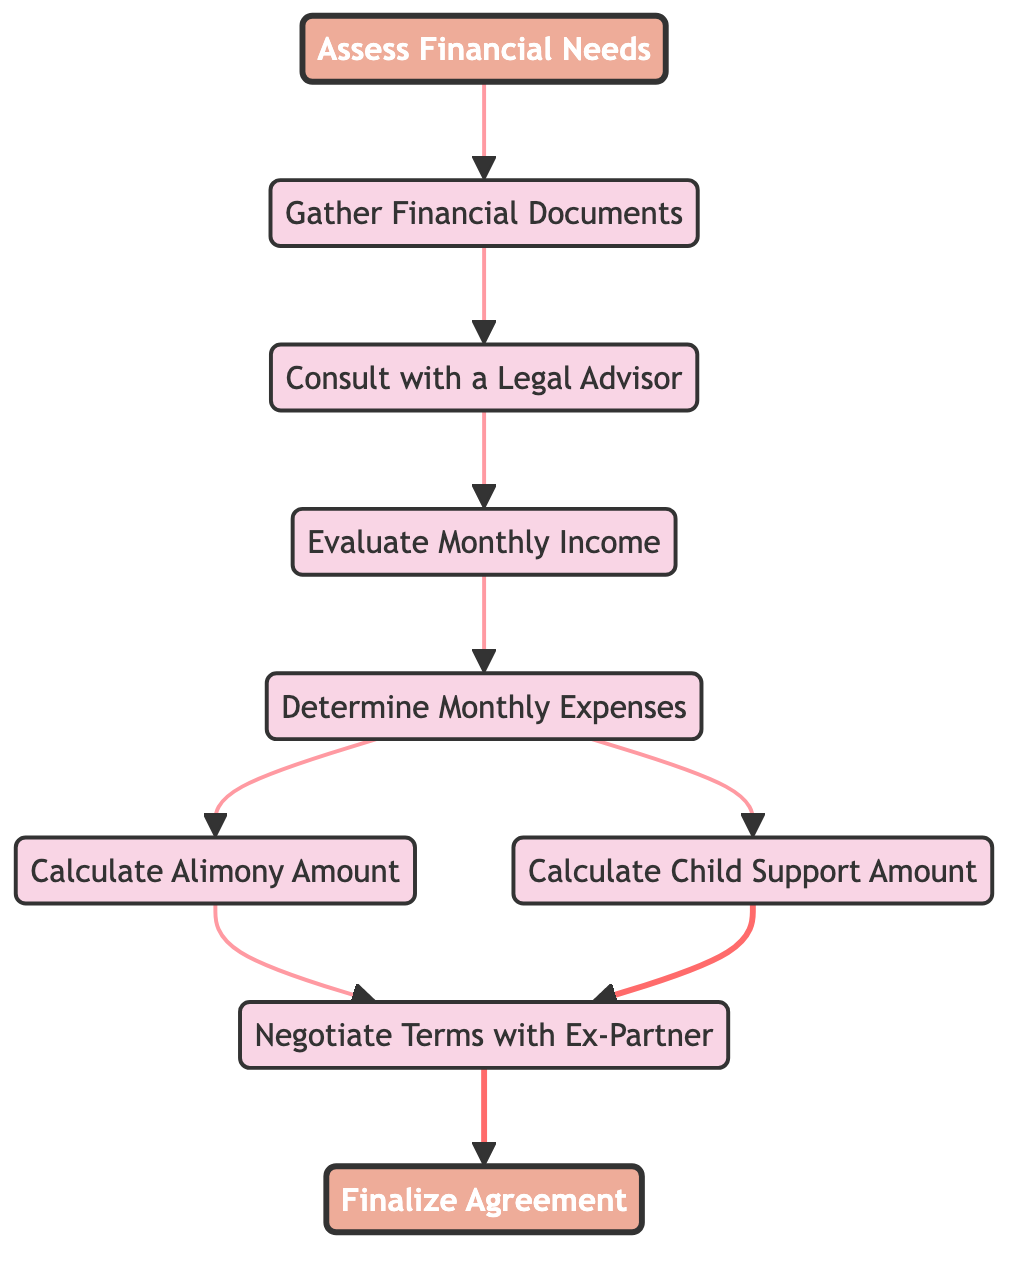What is the first step in the financial decision-making process? The diagram starts at the node "Assess Financial Needs," which is the first step depicted in the flowchart.
Answer: Assess Financial Needs How many total nodes are present in the diagram? Counting the listed nodes, we see that there are nine distinct nodes in the financial decision-making flowchart.
Answer: 9 What is the last step before finalizing the agreement? The flowchart shows "Negotiate Terms with Ex-Partner" as the last step before moving to the "Finalize Agreement."
Answer: Negotiate Terms with Ex-Partner Which nodes directly lead to determining expenses? The node "Evaluate Monthly Income" directly leads to the "Determine Monthly Expenses" node as per the connection in the diagram.
Answer: Evaluate Monthly Income What are the two calculations performed after determining expenses? After "Determine Monthly Expenses," the two nodes that follow are "Calculate Alimony Amount" and "Calculate Child Support Amount."
Answer: Calculate Alimony Amount and Calculate Child Support Amount Which step comes after gathering financial documents? The diagram indicates that "Consult with a Legal Advisor" follows after "Gather Financial Documents."
Answer: Consult with a Legal Advisor What do the edges represent in this directed graph? Each directed edge in the graph shows the flow or sequence of steps taken in the financial decision-making process concerning alimony and child support.
Answer: Flow/Sequence of steps How many edges connect to the "Negotiate Terms" node? The diagram shows that there are two edges leading into the "Negotiate Terms" node, one from "Calculate Alimony" and one from "Calculate Child Support."
Answer: 2 What action is taken after consulting with a legal advisor? Following the "Consult with a Legal Advisor," the next action is to "Evaluate Monthly Income," as shown in the diagram.
Answer: Evaluate Monthly Income 